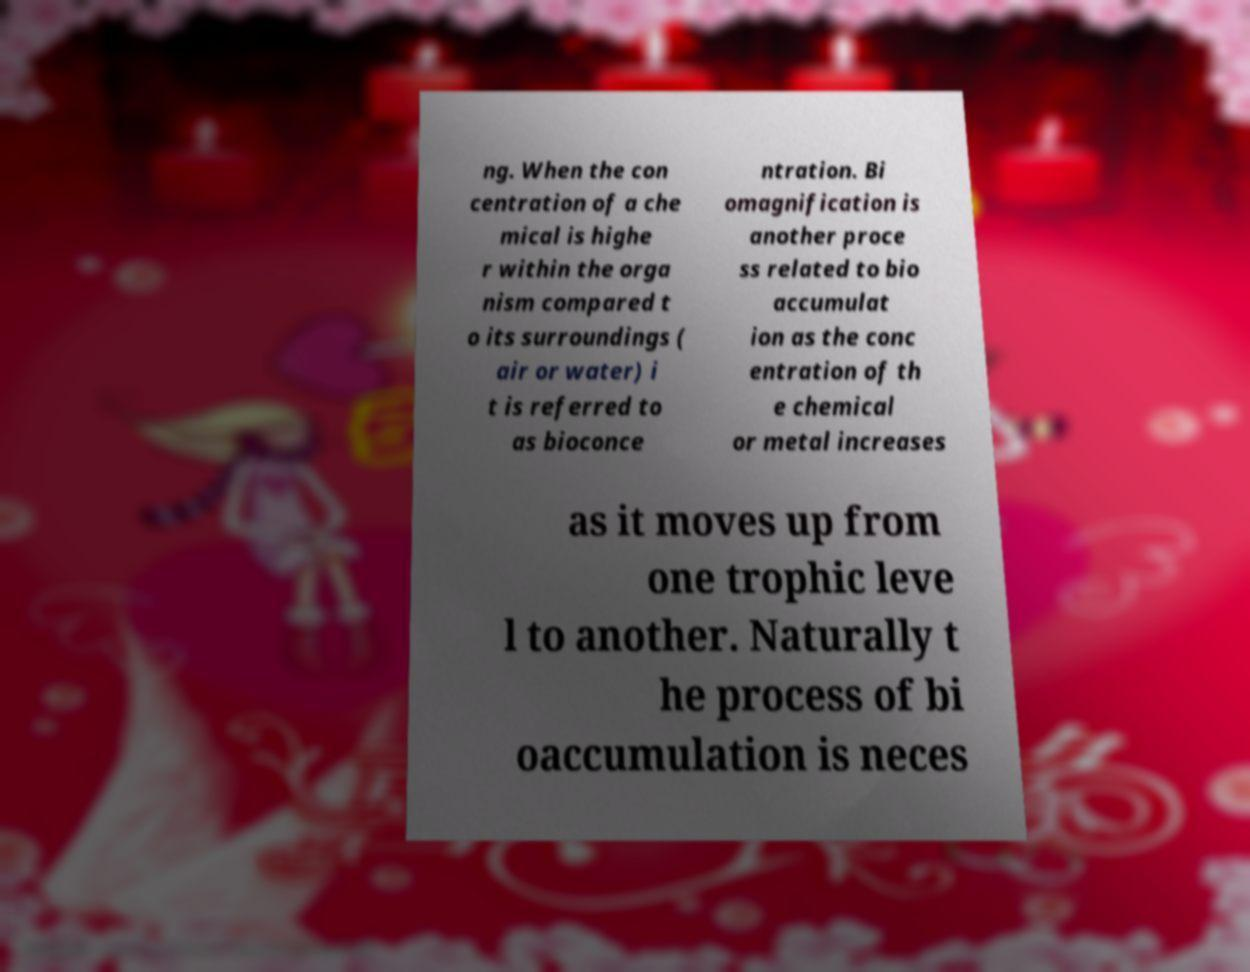Could you assist in decoding the text presented in this image and type it out clearly? ng. When the con centration of a che mical is highe r within the orga nism compared t o its surroundings ( air or water) i t is referred to as bioconce ntration. Bi omagnification is another proce ss related to bio accumulat ion as the conc entration of th e chemical or metal increases as it moves up from one trophic leve l to another. Naturally t he process of bi oaccumulation is neces 